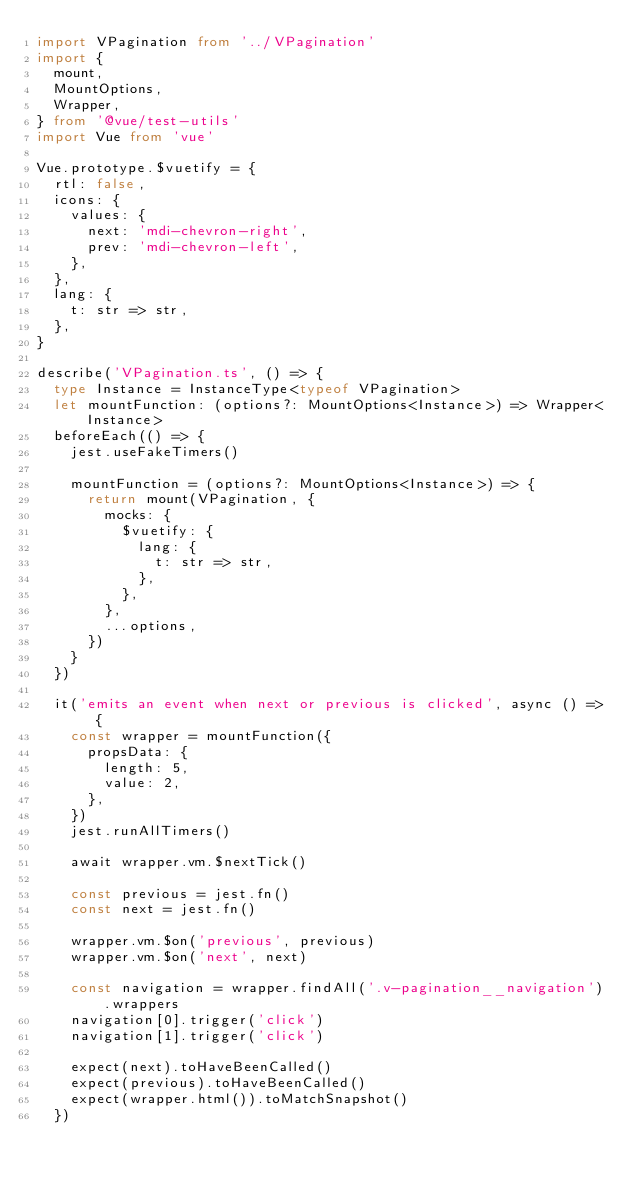Convert code to text. <code><loc_0><loc_0><loc_500><loc_500><_TypeScript_>import VPagination from '../VPagination'
import {
  mount,
  MountOptions,
  Wrapper,
} from '@vue/test-utils'
import Vue from 'vue'

Vue.prototype.$vuetify = {
  rtl: false,
  icons: {
    values: {
      next: 'mdi-chevron-right',
      prev: 'mdi-chevron-left',
    },
  },
  lang: {
    t: str => str,
  },
}

describe('VPagination.ts', () => {
  type Instance = InstanceType<typeof VPagination>
  let mountFunction: (options?: MountOptions<Instance>) => Wrapper<Instance>
  beforeEach(() => {
    jest.useFakeTimers()

    mountFunction = (options?: MountOptions<Instance>) => {
      return mount(VPagination, {
        mocks: {
          $vuetify: {
            lang: {
              t: str => str,
            },
          },
        },
        ...options,
      })
    }
  })

  it('emits an event when next or previous is clicked', async () => {
    const wrapper = mountFunction({
      propsData: {
        length: 5,
        value: 2,
      },
    })
    jest.runAllTimers()

    await wrapper.vm.$nextTick()

    const previous = jest.fn()
    const next = jest.fn()

    wrapper.vm.$on('previous', previous)
    wrapper.vm.$on('next', next)

    const navigation = wrapper.findAll('.v-pagination__navigation').wrappers
    navigation[0].trigger('click')
    navigation[1].trigger('click')

    expect(next).toHaveBeenCalled()
    expect(previous).toHaveBeenCalled()
    expect(wrapper.html()).toMatchSnapshot()
  })
</code> 